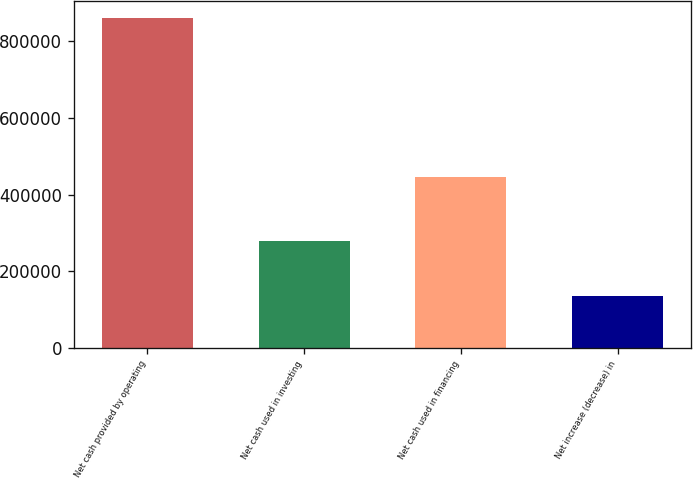Convert chart to OTSL. <chart><loc_0><loc_0><loc_500><loc_500><bar_chart><fcel>Net cash provided by operating<fcel>Net cash used in investing<fcel>Net cash used in financing<fcel>Net increase (decrease) in<nl><fcel>861454<fcel>278334<fcel>447091<fcel>136029<nl></chart> 